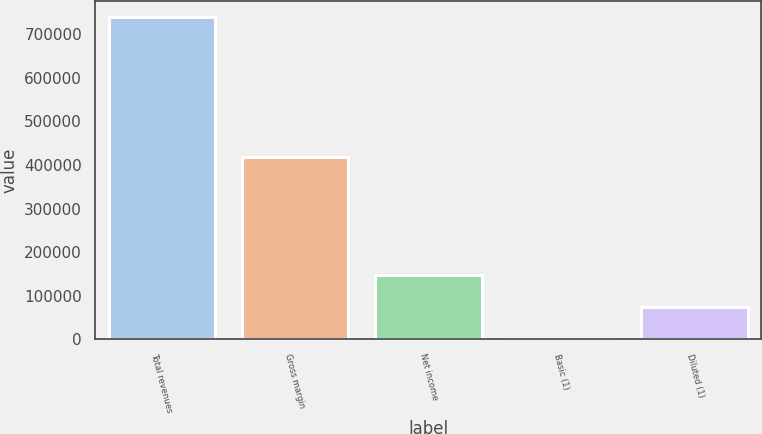Convert chart to OTSL. <chart><loc_0><loc_0><loc_500><loc_500><bar_chart><fcel>Total revenues<fcel>Gross margin<fcel>Net income<fcel>Basic (1)<fcel>Diluted (1)<nl><fcel>738459<fcel>418177<fcel>147692<fcel>0.81<fcel>73846.6<nl></chart> 